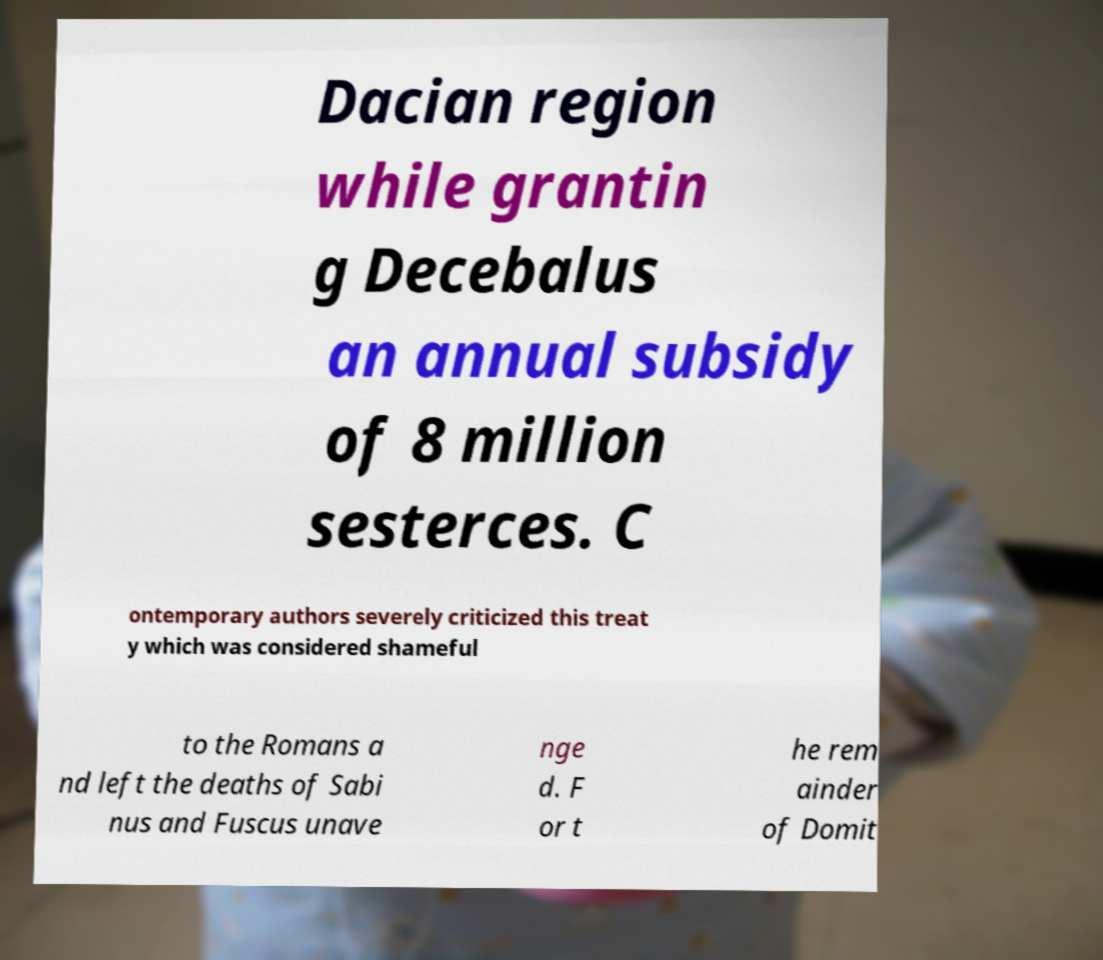I need the written content from this picture converted into text. Can you do that? Dacian region while grantin g Decebalus an annual subsidy of 8 million sesterces. C ontemporary authors severely criticized this treat y which was considered shameful to the Romans a nd left the deaths of Sabi nus and Fuscus unave nge d. F or t he rem ainder of Domit 